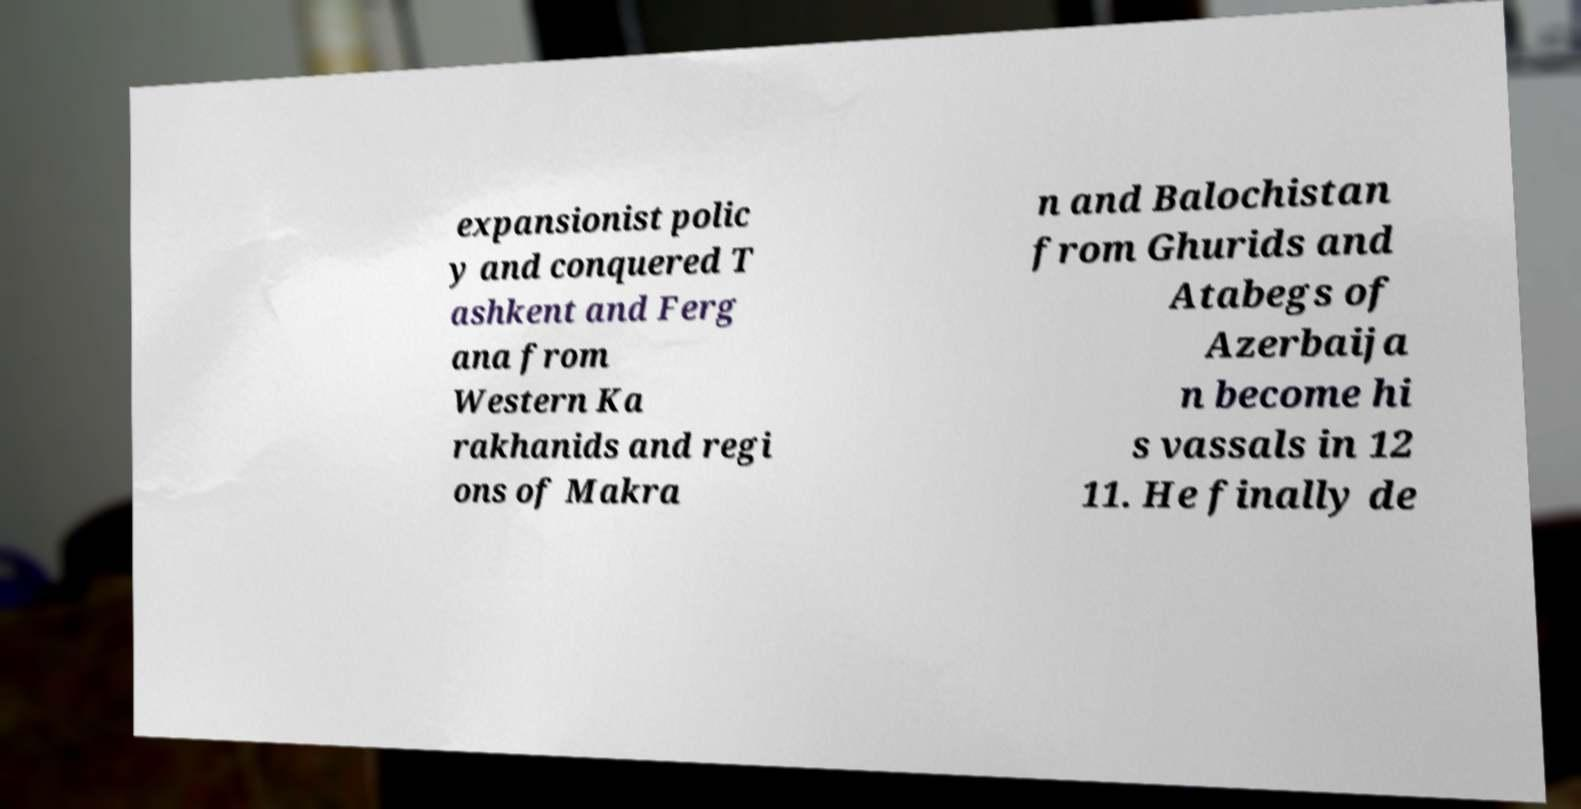Could you extract and type out the text from this image? expansionist polic y and conquered T ashkent and Ferg ana from Western Ka rakhanids and regi ons of Makra n and Balochistan from Ghurids and Atabegs of Azerbaija n become hi s vassals in 12 11. He finally de 